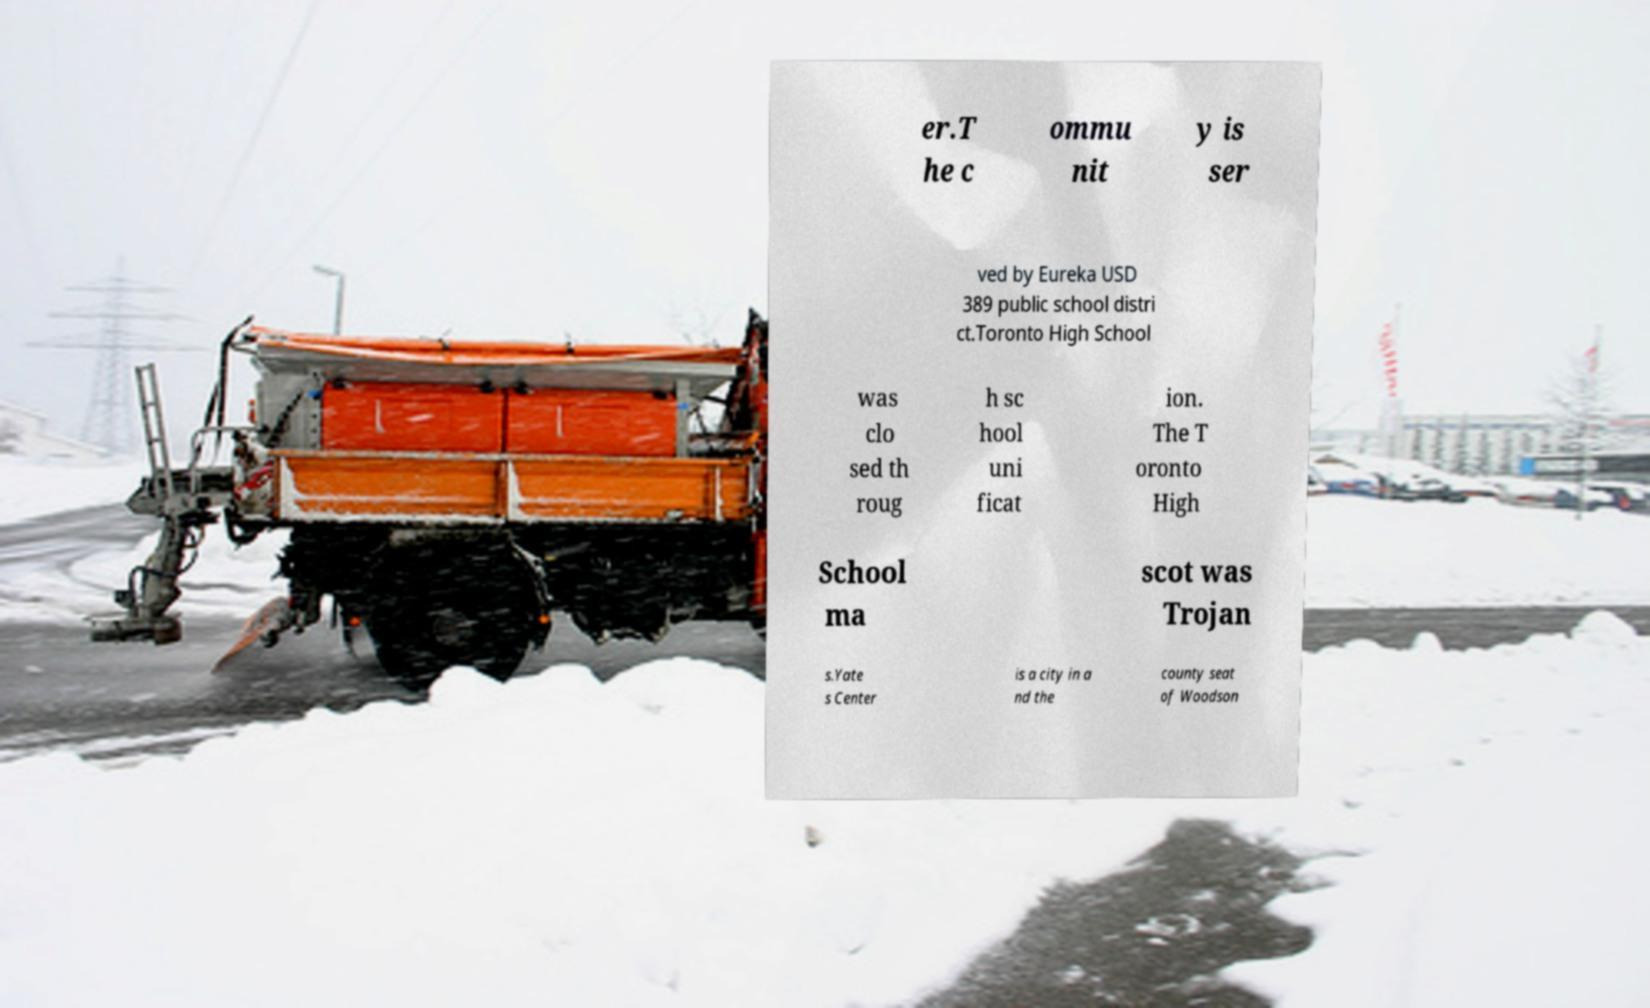Could you assist in decoding the text presented in this image and type it out clearly? er.T he c ommu nit y is ser ved by Eureka USD 389 public school distri ct.Toronto High School was clo sed th roug h sc hool uni ficat ion. The T oronto High School ma scot was Trojan s.Yate s Center is a city in a nd the county seat of Woodson 